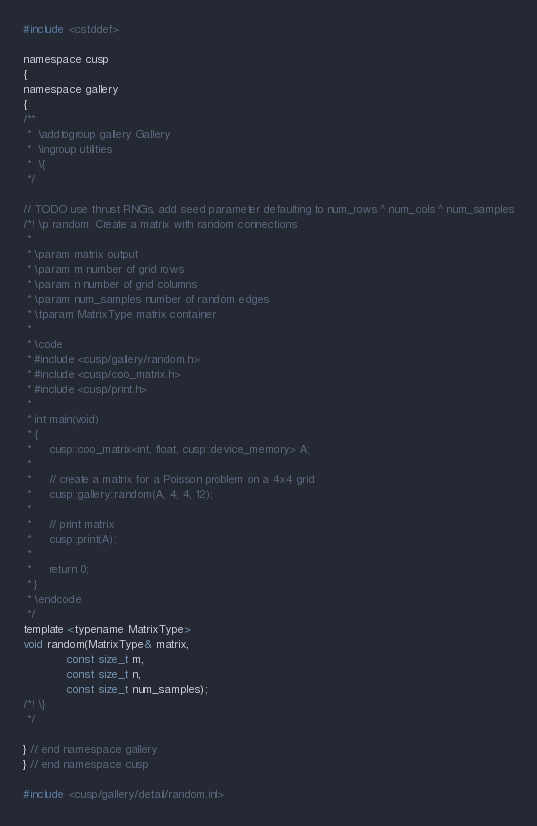<code> <loc_0><loc_0><loc_500><loc_500><_C_>
#include <cstddef>

namespace cusp
{
namespace gallery
{
/**
 *  \addtogroup gallery Gallery
 *  \ingroup utilities
 *  \{
 */

// TODO use thrust RNGs, add seed parameter defaulting to num_rows ^ num_cols ^ num_samples
/*! \p random: Create a matrix with random connections
 *
 * \param matrix output
 * \param m number of grid rows
 * \param n number of grid columns
 * \param num_samples number of random edges
 * \tparam MatrixType matrix container
 *
 * \code
 * #include <cusp/gallery/random.h>
 * #include <cusp/coo_matrix.h>
 * #include <cusp/print.h>
 *
 * int main(void)
 * {
 *     cusp::coo_matrix<int, float, cusp::device_memory> A;
 *
 *     // create a matrix for a Poisson problem on a 4x4 grid
 *     cusp::gallery::random(A, 4, 4, 12);
 *
 *     // print matrix
 *     cusp::print(A);
 *
 *     return 0;
 * }
 * \endcode
 */
template <typename MatrixType>
void random(MatrixType& matrix,
            const size_t m,
            const size_t n,
            const size_t num_samples);
/*! \}
 */

} // end namespace gallery
} // end namespace cusp

#include <cusp/gallery/detail/random.inl>
</code> 